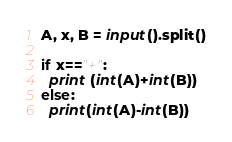Convert code to text. <code><loc_0><loc_0><loc_500><loc_500><_Python_>A, x, B = input().split()

if x=="+":
  print (int(A)+int(B))
else:
  print(int(A)-int(B))</code> 